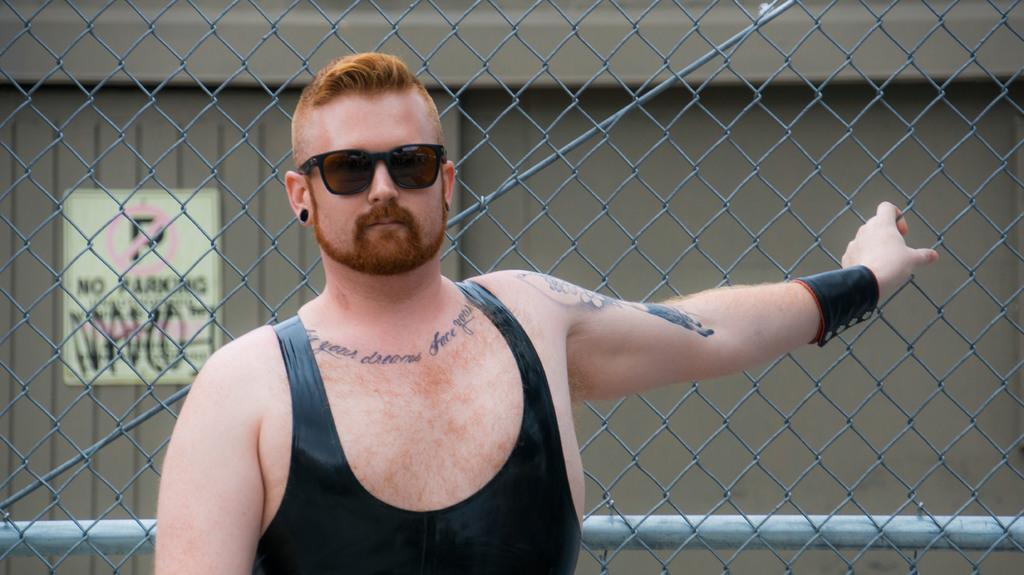What is the main subject of the image? The main subject of the image is a man. What is the man wearing on his face? The man is wearing goggles. What type of clothing is the man wearing on his upper body? The man is wearing a black vest. Are there any accessories visible on the man? Yes, the man is wearing a black earring and a black band. Are there any visible markings or designs on the man's body? Yes, the man has tattoos on his body. What can be seen behind the man in the image? There is a fence behind the man. What is present at the left back of the man in the image? There is a sign board at the left back of the man. What type of vegetable is the man holding in the image? There is no vegetable present in the image; the man is not holding anything. What kind of bread can be seen on the fence in the image? There is no bread visible on the fence in the image. 